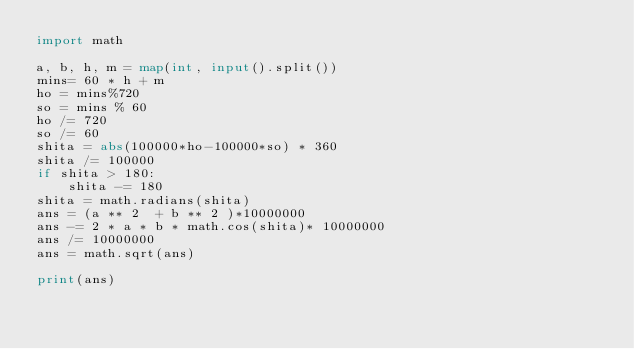<code> <loc_0><loc_0><loc_500><loc_500><_Python_>import math

a, b, h, m = map(int, input().split())
mins= 60 * h + m
ho = mins%720
so = mins % 60
ho /= 720
so /= 60
shita = abs(100000*ho-100000*so) * 360
shita /= 100000
if shita > 180:
    shita -= 180
shita = math.radians(shita)
ans = (a ** 2  + b ** 2 )*10000000
ans -= 2 * a * b * math.cos(shita)* 10000000
ans /= 10000000
ans = math.sqrt(ans)

print(ans)
</code> 